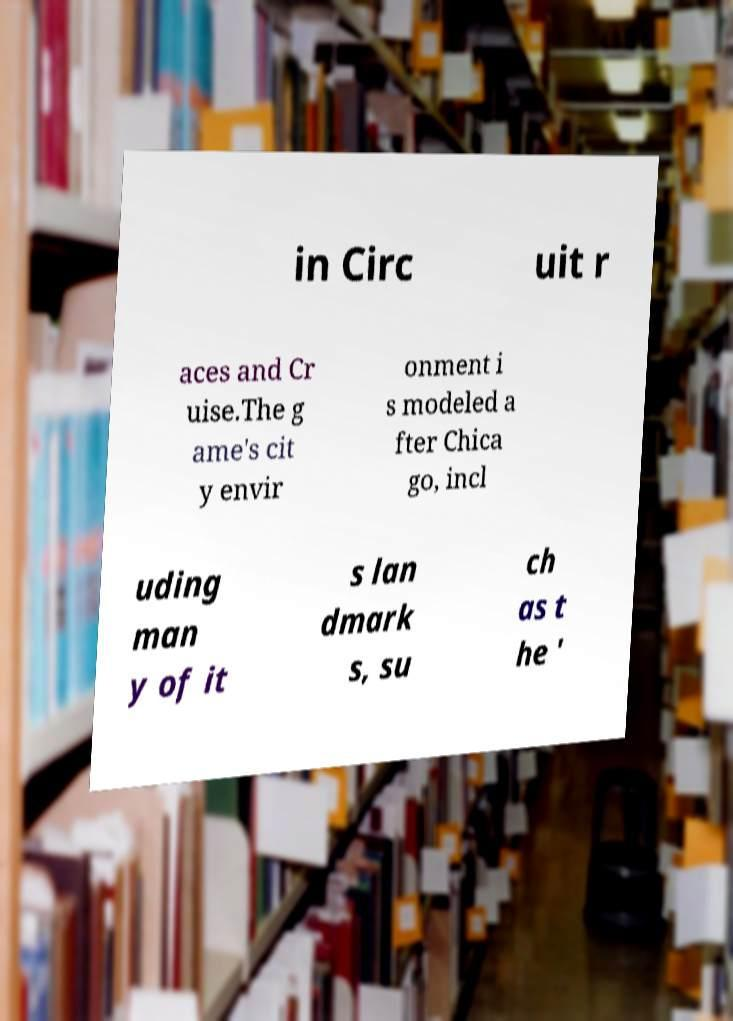Could you extract and type out the text from this image? in Circ uit r aces and Cr uise.The g ame's cit y envir onment i s modeled a fter Chica go, incl uding man y of it s lan dmark s, su ch as t he ' 